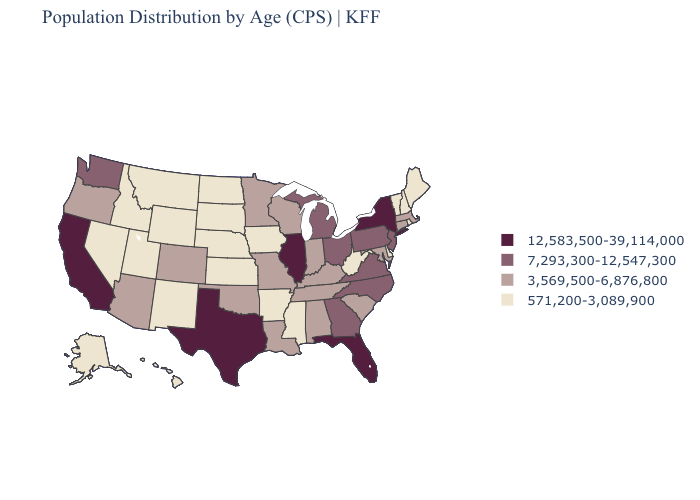Name the states that have a value in the range 7,293,300-12,547,300?
Quick response, please. Georgia, Michigan, New Jersey, North Carolina, Ohio, Pennsylvania, Virginia, Washington. Name the states that have a value in the range 12,583,500-39,114,000?
Short answer required. California, Florida, Illinois, New York, Texas. Among the states that border Indiana , which have the lowest value?
Concise answer only. Kentucky. What is the highest value in the MidWest ?
Answer briefly. 12,583,500-39,114,000. What is the value of Montana?
Answer briefly. 571,200-3,089,900. Does Alaska have the lowest value in the USA?
Short answer required. Yes. Does the first symbol in the legend represent the smallest category?
Be succinct. No. What is the value of North Dakota?
Keep it brief. 571,200-3,089,900. What is the value of Florida?
Give a very brief answer. 12,583,500-39,114,000. Does Montana have a lower value than Alaska?
Answer briefly. No. Does the map have missing data?
Give a very brief answer. No. Which states have the lowest value in the USA?
Be succinct. Alaska, Arkansas, Delaware, Hawaii, Idaho, Iowa, Kansas, Maine, Mississippi, Montana, Nebraska, Nevada, New Hampshire, New Mexico, North Dakota, Rhode Island, South Dakota, Utah, Vermont, West Virginia, Wyoming. Which states have the lowest value in the MidWest?
Give a very brief answer. Iowa, Kansas, Nebraska, North Dakota, South Dakota. Name the states that have a value in the range 3,569,500-6,876,800?
Keep it brief. Alabama, Arizona, Colorado, Connecticut, Indiana, Kentucky, Louisiana, Maryland, Massachusetts, Minnesota, Missouri, Oklahoma, Oregon, South Carolina, Tennessee, Wisconsin. What is the value of Pennsylvania?
Answer briefly. 7,293,300-12,547,300. 